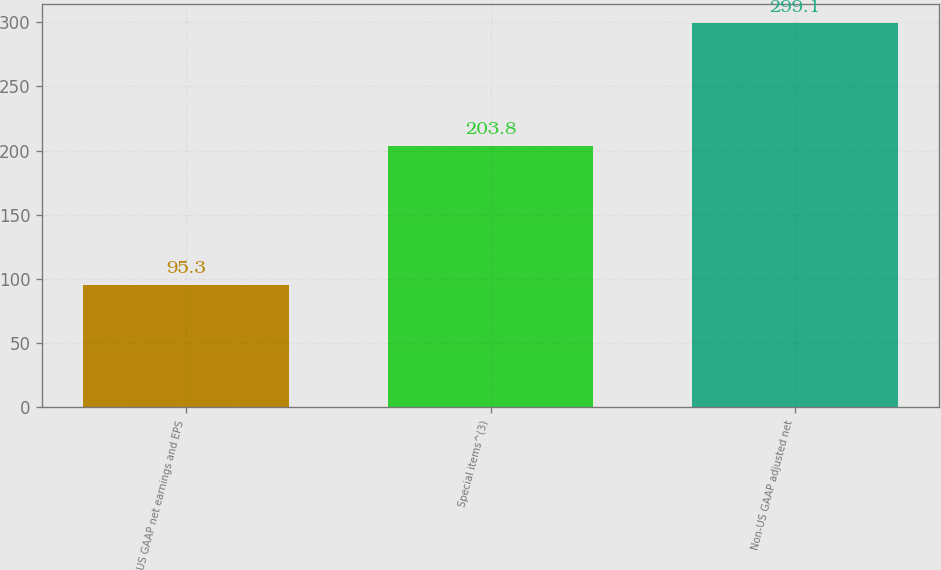Convert chart to OTSL. <chart><loc_0><loc_0><loc_500><loc_500><bar_chart><fcel>US GAAP net earnings and EPS<fcel>Special items^(3)<fcel>Non-US GAAP adjusted net<nl><fcel>95.3<fcel>203.8<fcel>299.1<nl></chart> 